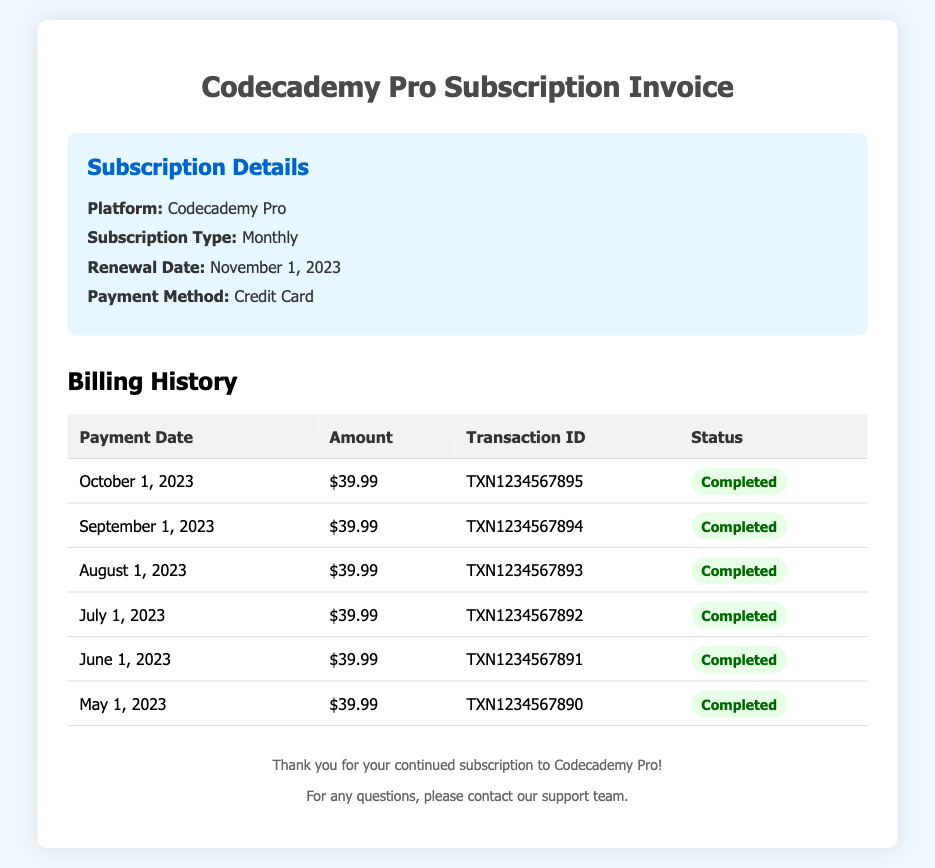what is the subscription type? The subscription type is mentioned in the subscription details section of the document.
Answer: Monthly what is the renewal date? The renewal date is provided as part of the subscription details section.
Answer: November 1, 2023 how much is the monthly fee? The amount charged each month is listed in the billing history for each payment.
Answer: $39.99 when was the last payment made? The last payment date is indicated in the billing history table.
Answer: October 1, 2023 what payment method is used? The document specifies the payment method used for the subscription.
Answer: Credit Card how many completed payments are listed? The document shows the number of completed payments in the billing history section.
Answer: 6 what is the transaction ID for the payment made in September 2023? The transaction ID is included in the billing history table for that specific date.
Answer: TXN1234567894 what status is shown for the payments? The status of each payment is mentioned in the billing history table.
Answer: Completed how many months of billing history are shown? The document states the number of months covered in the billing history.
Answer: 6 